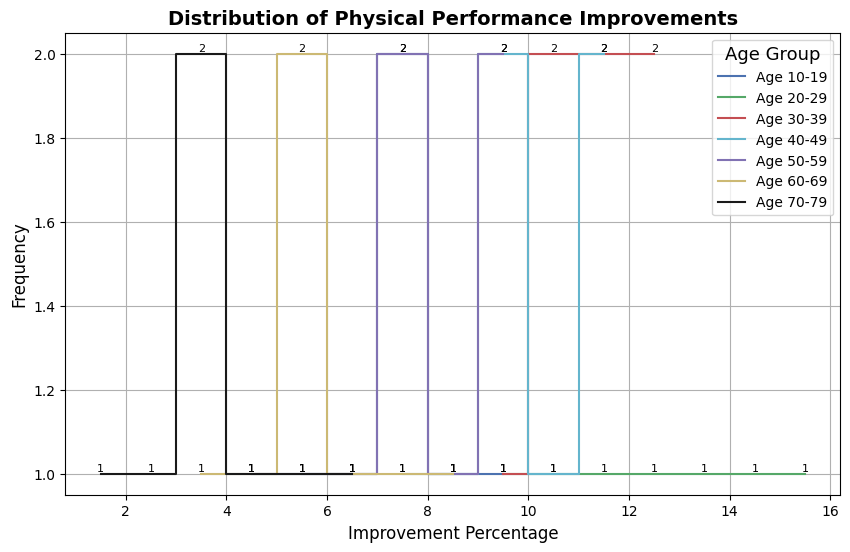Which age group shows the highest maximum improvement percentage? By inspecting the highest values on each step line, the age group 20-29 has the highest maximum improvement percentage at 16%.
Answer: 20-29 What is the range of improvement percentages for the age group 10-19? The minimum improvement percentage for the age group 10-19 is 5%, and the maximum is 10%. Therefore, the range is 10% - 5% = 5%.
Answer: 5% Which age group has the most frequent improvement percentage value at 10%? Observing the height of steps at 10% across all age groups, age groups 20-29 and 50-59 both have peaks at 10%, but 20-29 has a higher frequency count (beginning from 10 and moving upwards).
Answer: 20-29 What is the average improvement percentage for the age group 60-69? The improvement percentages for the age group 60-69 are 4, 5, 6, 6, 7, 8, 9. Adding them gives 45, and dividing by the number of data points (7) gives an average of 45 / 7 ≈ 6.43.
Answer: ≈6.43 What is the most common improvement percentage for age group 40-49? The highest peak in the step plot for age group 40-49 occurs at 10% with the highest frequency count.
Answer: 10% Compare the age groups 30-39 and 70-79: Which group has a higher median improvement percentage? The sorted improvements for 30-39 are 10, 11, 11, 12, 12, 13, 13 and for 70-79, they are 2, 3, 4, 4, 5, 6, 7. The median for 30-39 is 12, and for 70-79, it is 4. Therefore, 30-39 has a higher median improvement percentage.
Answer: 30-39 How many improvement percentage values are there for the age group 50-59 between 8 and 10 inclusive? For the age group 50-59, the values 8, 8, 9, 10, and 10 fall within the range 8-10. This makes a total count of 5 values.
Answer: 5 Which age group shows the smallest variation in improvement percentages? By examining the tightness of the range of step heights, the age group 70-79 has the smallest variation (2 to 7), giving a range of 5.
Answer: 70-79 Which age groups have their most frequent improvement percentages at 8%? The highest frequencies at 8% are for age groups 10-19 and 50-59.
Answer: 10-19 and 50-59 